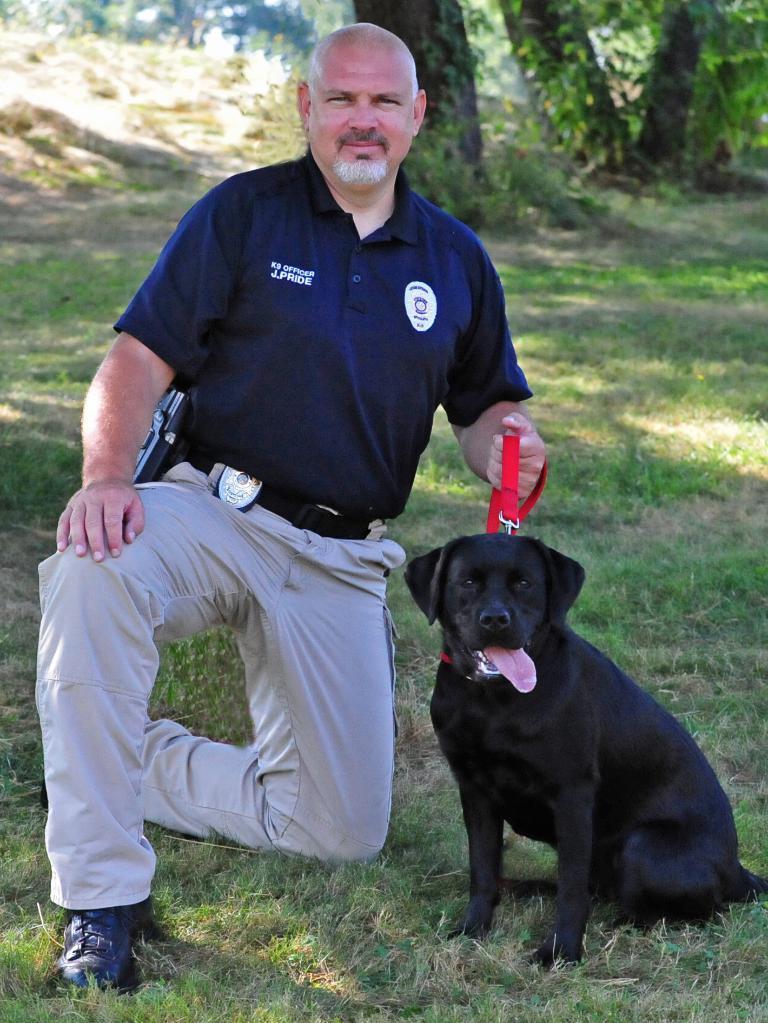Can you describe this image briefly? In this image, there is an outside view. There is a person person wearing clothes and holding a dog with leash. There is a grass on the ground. 